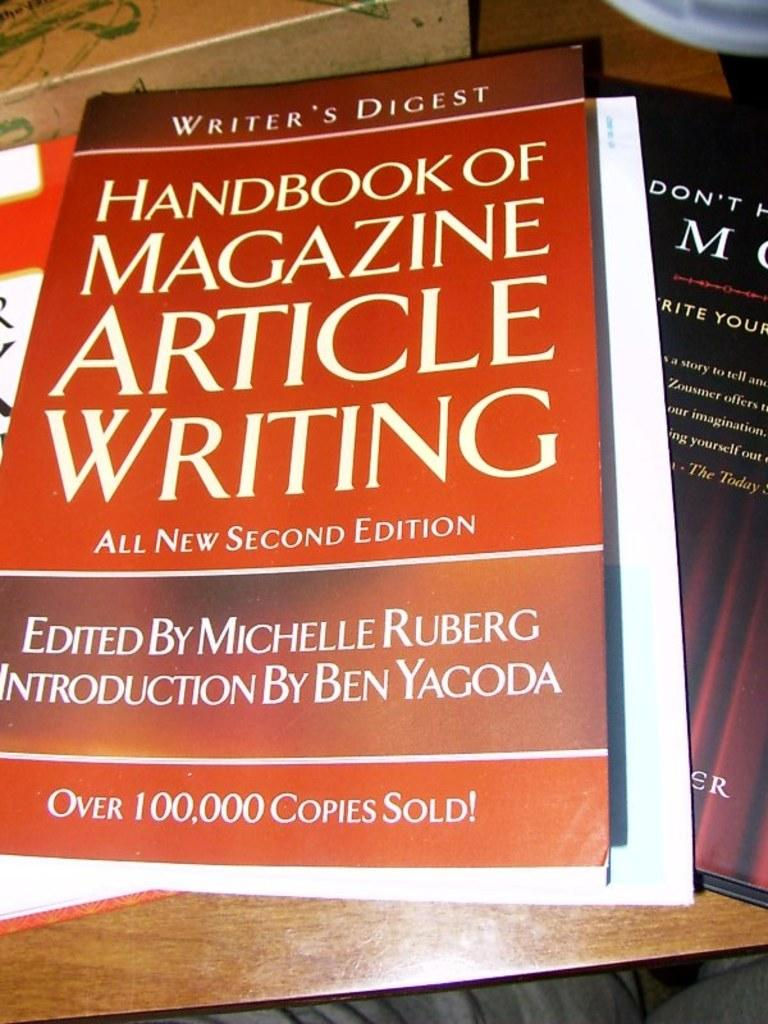Provide a one-sentence caption for the provided image. A large book titled HANDBOOK OF MAGAZINE ARTICLE WRITING. 